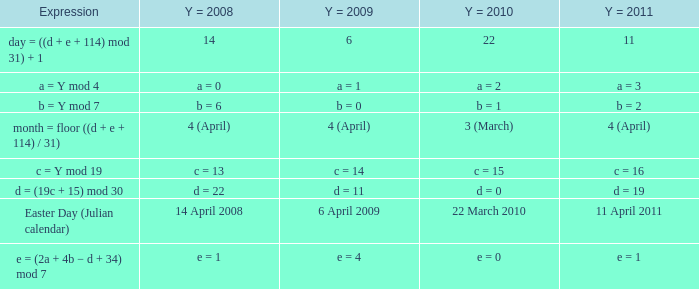What is the y = 2011 when the expression is month = floor ((d + e + 114) / 31)? 4 (April). 